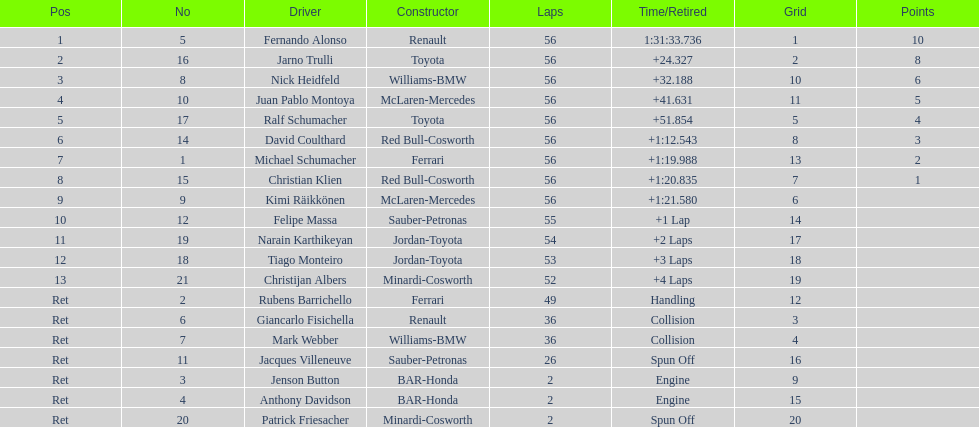How many bmw vehicles completed the race ahead of webber? 1. 